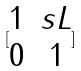<formula> <loc_0><loc_0><loc_500><loc_500>[ \begin{matrix} 1 & s L \\ 0 & 1 \end{matrix} ]</formula> 